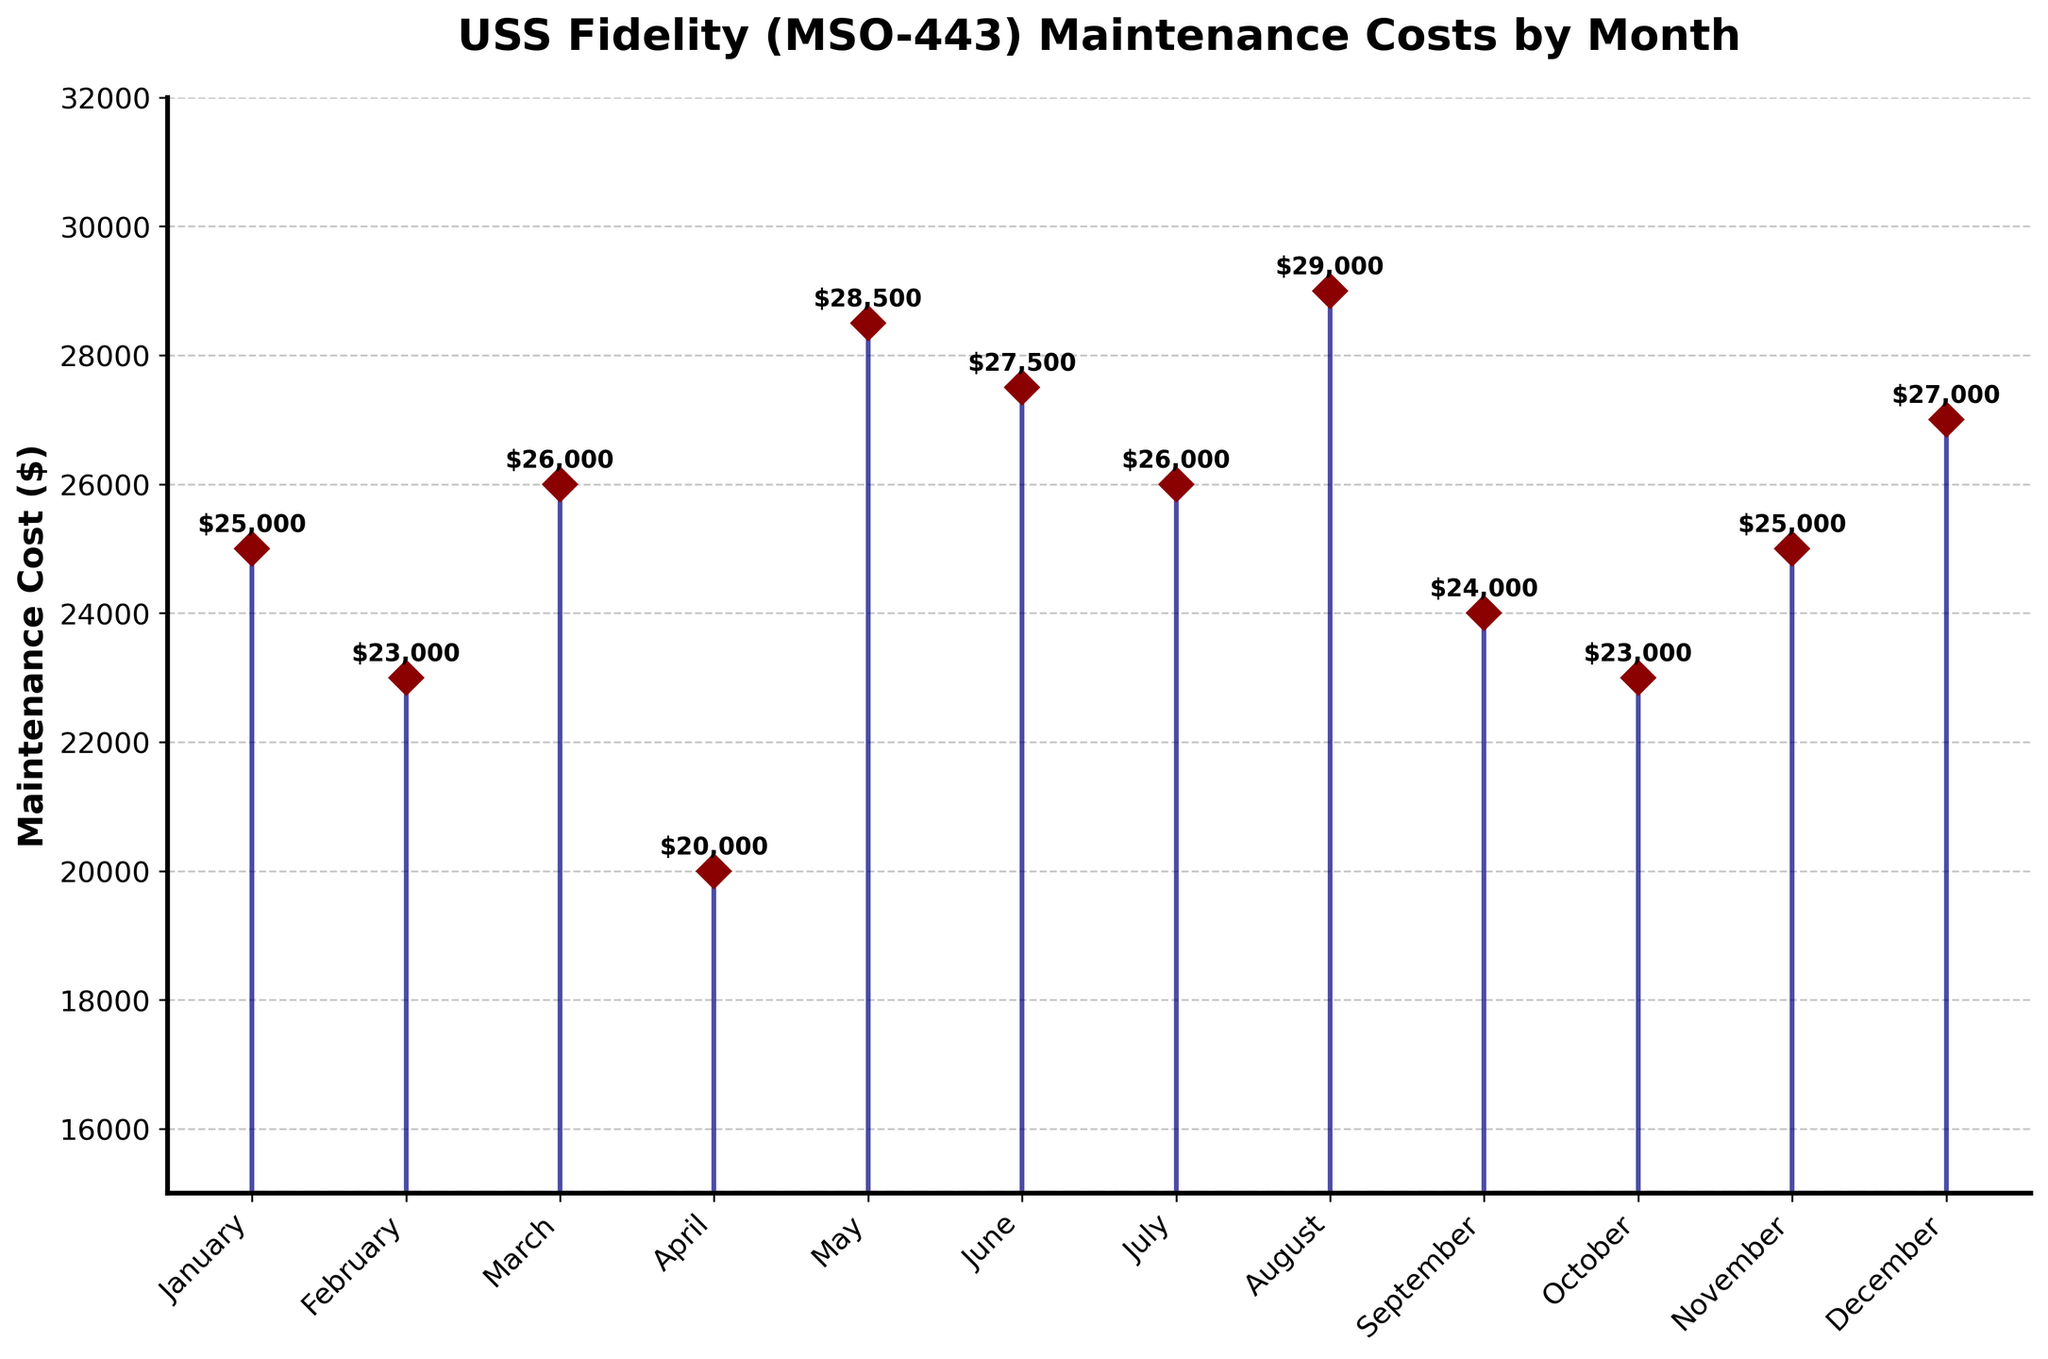what is the title of the figure? The title is found at the top of the figure, usually in larger, bold text. It provides an overview of what the figure is about.
Answer: USS Fidelity (MSO-443) Maintenance Costs by Month What is the marker shape used in the plot? Markers in the plot are small shapes used to indicate data points. By observing the plot, one can identify the specific shape used.
Answer: Diamond (D) Which month had the highest maintenance cost and how much was it? To find the highest maintenance cost, look for the tallest stem in the plot and note the corresponding month and value.
Answer: August, $29,000 What is the range of the y-axis values? The range of the y-axis values can be determined by looking at the minimum and maximum values specified on the y-axis.
Answer: $15,000 to $32,000 What is the average maintenance cost over the year? Sum all monthly maintenance costs and then divide by 12 (number of months). The summed cost is ($25,000 + $23,000 + $26,000 + $20,000 + $28,500 + $27,500 + $26,000 + $29,000 + $24,000 + $23,000 + $25,000 + $27,000) = $304,000. Dividing by 12 gives the average.
Answer: $25,333.33 What is the difference in maintenance costs between May and November? Find the maintenance costs for May and November from the plot, then subtract the November cost from the May cost. May: $28,500, November: $25,000. The difference is $28,500 - $25,000.
Answer: $3,500 What is the total maintenance cost in the second half of the year? Sum the costs from July to December. The costs are ($26,000 + $29,000 + $24,000 + $23,000 + $25,000 + $27,000) = $154,000.
Answer: $154,000 Which month had a lower maintenance cost, February or October? Compare the heights of the stems for February and October in the plot. February: $23,000, October: $23,000.
Answer: Equal Which are the lowest and highest maintenance costs, and in which month did they occur? Identify the shortest and tallest stems in the plot and note the corresponding months and costs. Lowest: April ($20,000), Highest: August ($29,000).
Answer: April: $20,000, August: $29,000 Summarize the general trend of maintenance costs throughout the year. By observing the plot, note whether the costs generally increase, decrease, or fluctuate. The costs vary somewhat but show peaks in May and August and a dip in April.
Answer: Fluctuating with peaks in May and August 